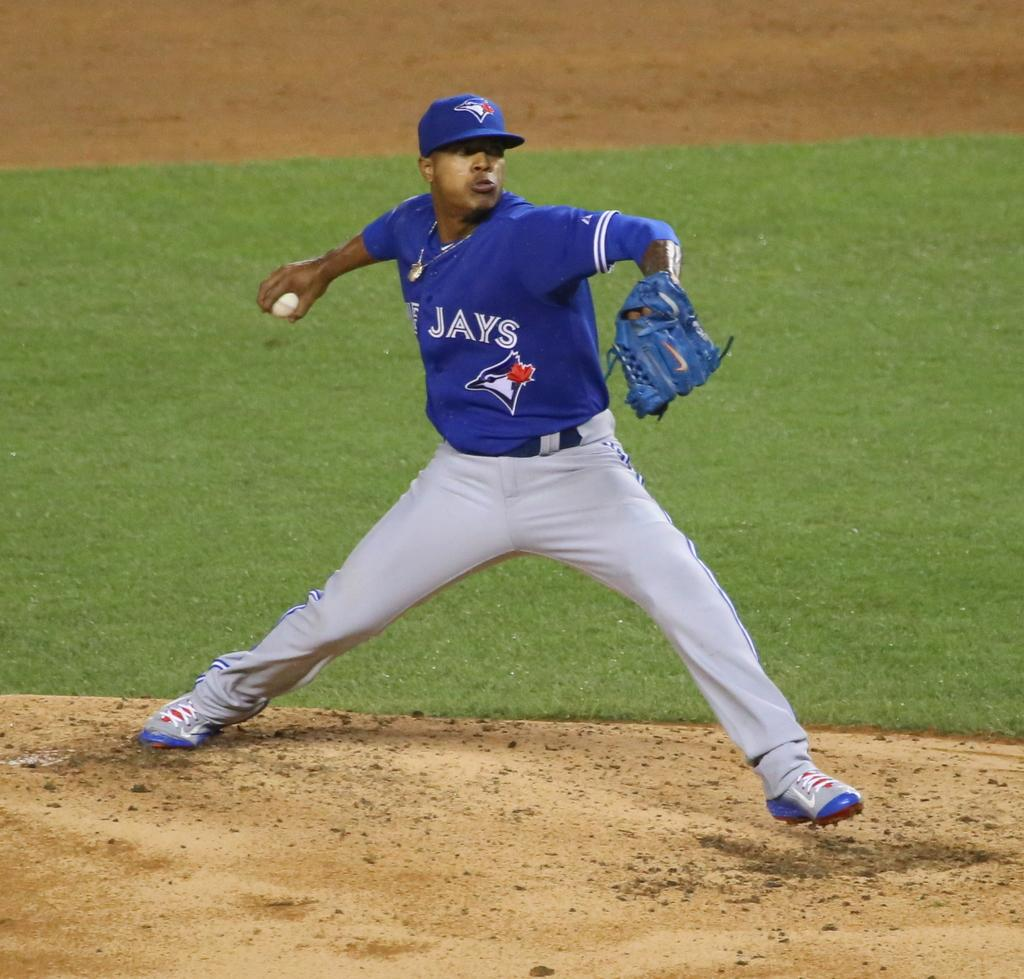<image>
Render a clear and concise summary of the photo. A Toronto Blue Jays pitcher prepares to throw a baseball. 